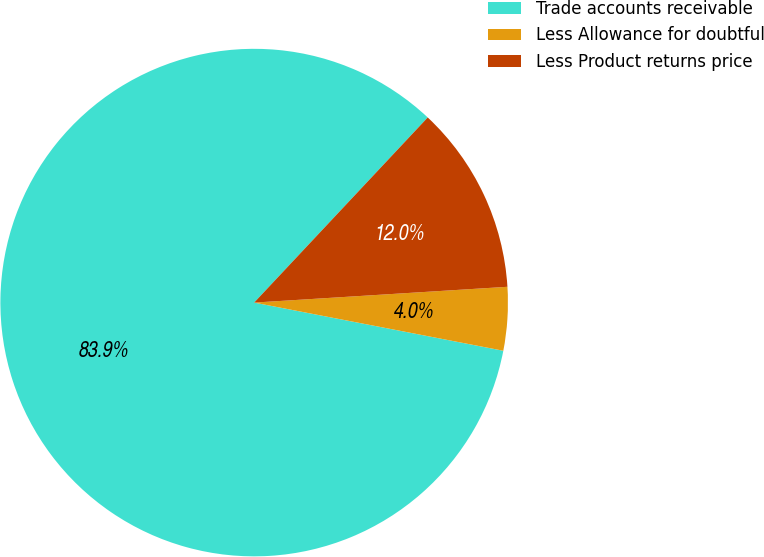Convert chart. <chart><loc_0><loc_0><loc_500><loc_500><pie_chart><fcel>Trade accounts receivable<fcel>Less Allowance for doubtful<fcel>Less Product returns price<nl><fcel>83.95%<fcel>4.03%<fcel>12.02%<nl></chart> 